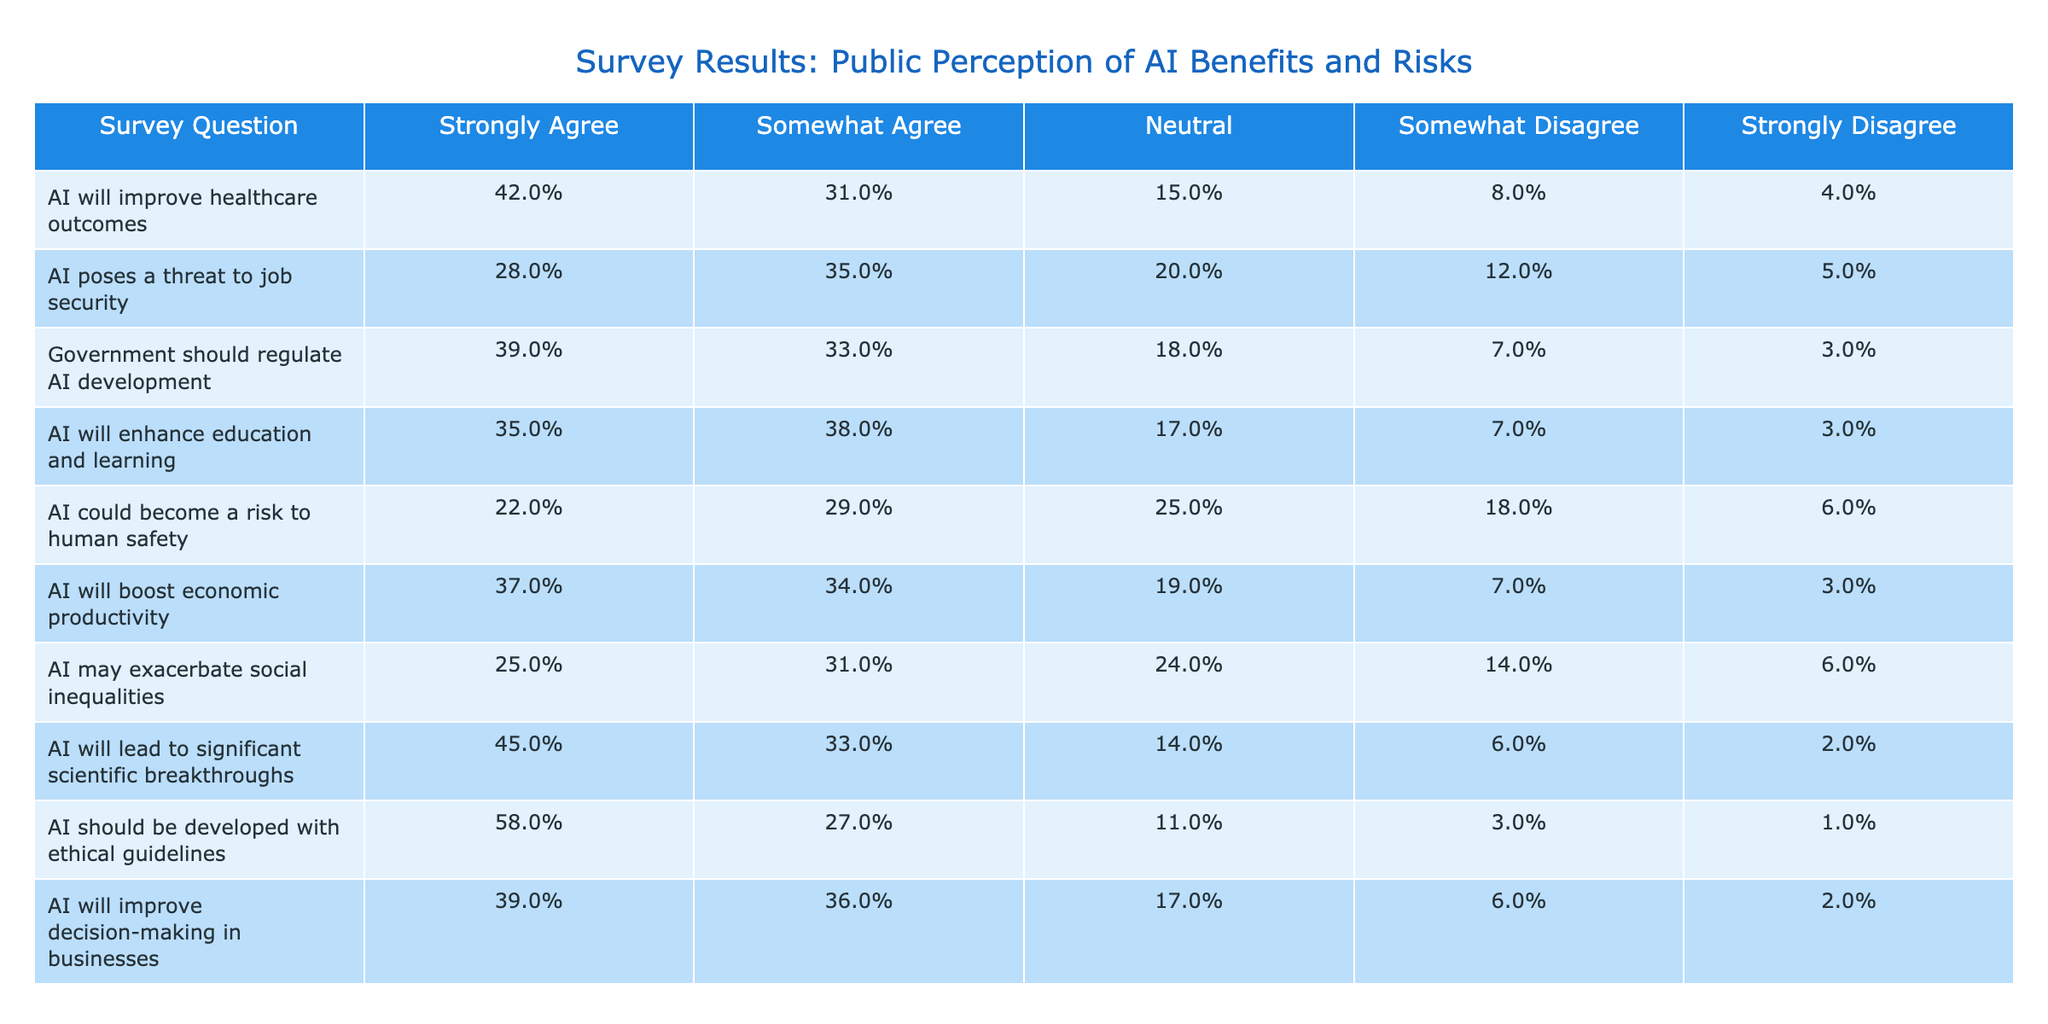What percentage of people strongly agree that AI will improve healthcare outcomes? According to the table, the percentage of people who strongly agree is specifically listed under that category corresponding to the question about AI improving healthcare outcomes. It shows as 42%.
Answer: 42% What is the total percentage of respondents who agree that AI enhances education and learning? To find this, we sum the percentages of "Strongly Agree" (35%) and "Somewhat Agree" (38%) for the education question. Thus, 35% + 38% = 73%.
Answer: 73% True or False: More people strongly agree that AI will lead to scientific breakthroughs than those who believe AI poses a threat to job security. The data shows that 45% strongly agree with significant scientific breakthroughs and 28% strongly agree AI poses a threat to job security. 45% is greater than 28%, so the statement is true.
Answer: True What is the difference between the percentage of respondents who think AI will improve healthcare outcomes and those who believe it could risk human safety? The percentage for improving healthcare outcomes is 42% and for potential risk to human safety is 22%. The difference is calculated by subtracting 22% from 42%, which gives us 20%.
Answer: 20% How many more respondents support government regulation of AI development compared to those who see AI as a risk to job security? The percentages show that 39% support government regulation of AI development and 28% view AI as a job security risk. To find the difference, we subtract 28% from 39%, which results in 11%.
Answer: 11% What percentage of respondents is neutral about the statement that AI may exacerbate social inequalities? The neutral percentage for this risk is 24%, as indicated in the corresponding row of the table.
Answer: 24% If 1000 people participated in the survey, how many people believe that AI should be developed with ethical guidelines? The percentage for this belief is 58%. To find the number of people, we calculate 58% of 1000, which is 0.58 * 1000 = 580 people.
Answer: 580 people What are the average percentages of "Somewhat Disagree" across all survey questions? There are 10 questions and the "Somewhat Disagree" percentages are 8%, 12%, 7%, 7%, 18%, 7%, 14%, 6%, 3%, and 6%. Summing these gives 88%, then dividing by 10 gives an average of 8.8%.
Answer: 8.8% 